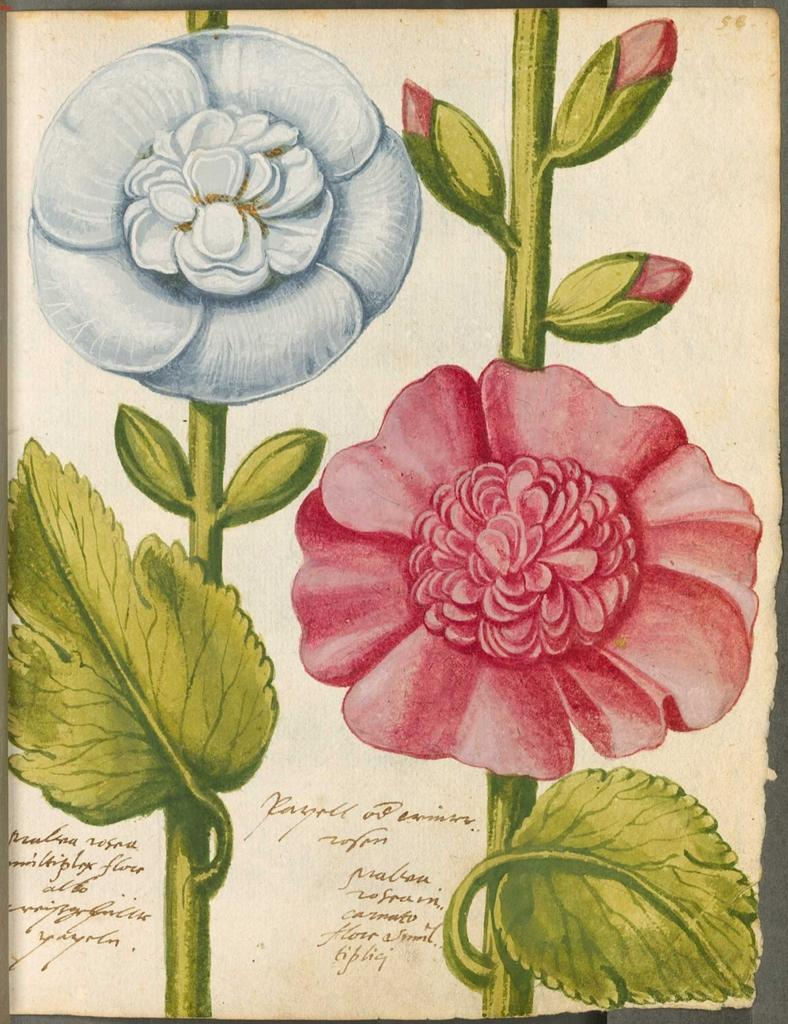What type of artwork is depicted in the image? The image is a painting. What natural elements can be seen in the painting? There are flowers and leaves in the painting. Is there any text present in the painting? Yes, there is text in the painting. How does the servant express regret in the painting? There is no servant or expression of regret present in the painting. What type of plate is used to serve the flowers in the painting? There is no plate present in the painting; it features flowers, leaves, and text. 